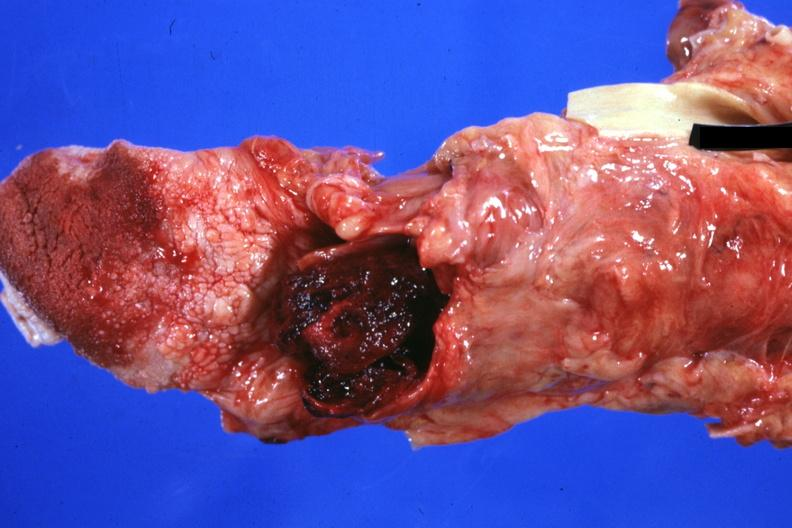what is present?
Answer the question using a single word or phrase. Oral 